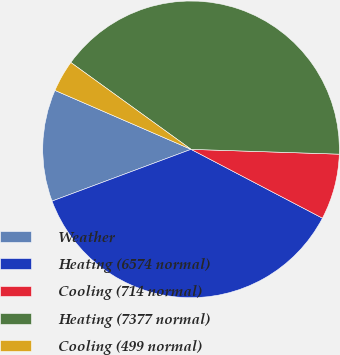Convert chart. <chart><loc_0><loc_0><loc_500><loc_500><pie_chart><fcel>Weather<fcel>Heating (6574 normal)<fcel>Cooling (714 normal)<fcel>Heating (7377 normal)<fcel>Cooling (499 normal)<nl><fcel>12.18%<fcel>36.65%<fcel>7.16%<fcel>40.56%<fcel>3.45%<nl></chart> 